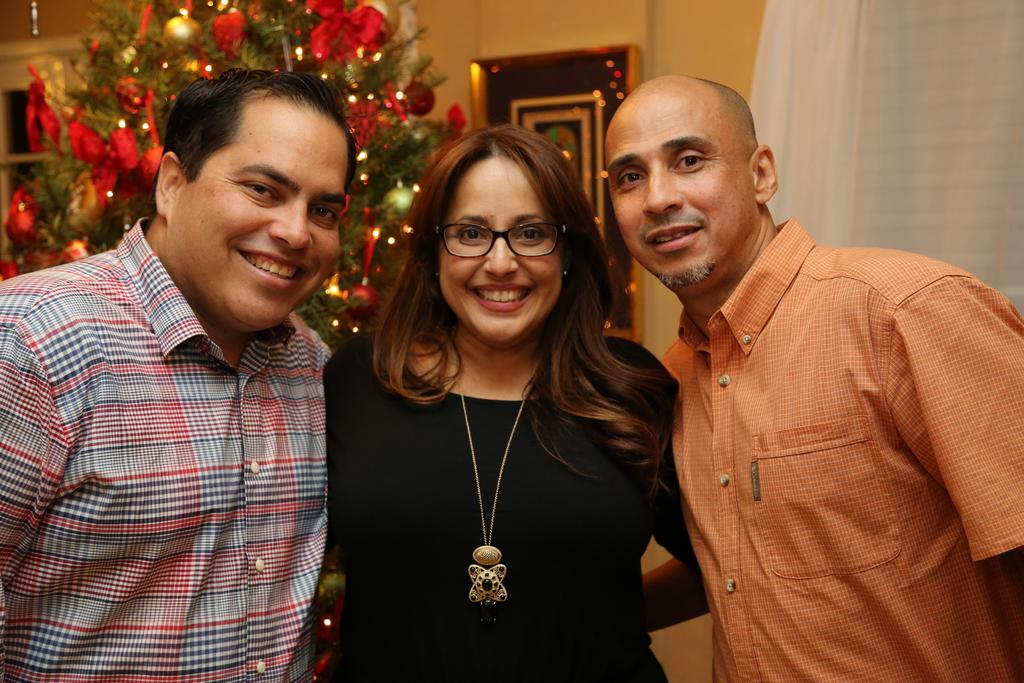How many people are in the image? There are three persons in the center of the image. What can be seen in the background of the image? There is a Christmas tree with decorations and lights, a photo frame, a wall, and a curtain in the background of the image. What type of story is being told by the dogs in the image? There are no dogs present in the image, so no story can be told by them. 